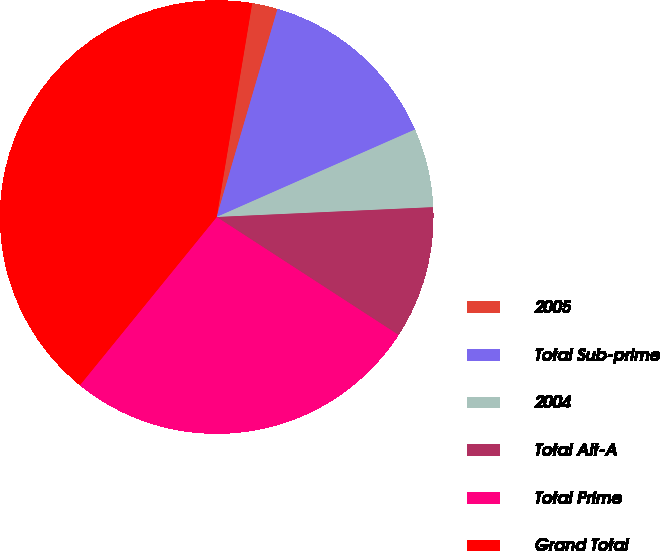Convert chart. <chart><loc_0><loc_0><loc_500><loc_500><pie_chart><fcel>2005<fcel>Total Sub-prime<fcel>2004<fcel>Total Alt-A<fcel>Total Prime<fcel>Grand Total<nl><fcel>1.91%<fcel>13.86%<fcel>5.89%<fcel>9.88%<fcel>26.71%<fcel>41.75%<nl></chart> 